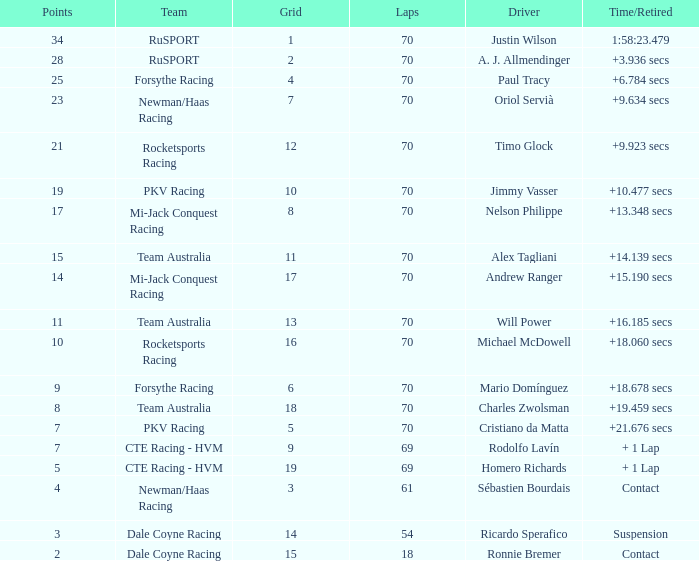Who scored with a grid of 10 and the highest amount of laps? 70.0. 